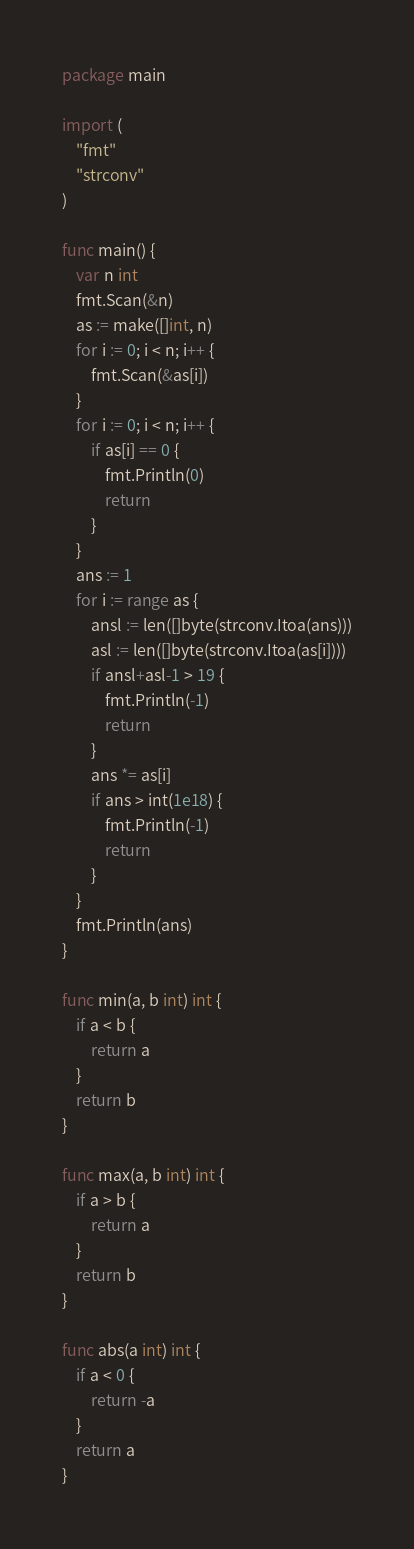Convert code to text. <code><loc_0><loc_0><loc_500><loc_500><_Go_>package main

import (
	"fmt"
	"strconv"
)

func main() {
	var n int
	fmt.Scan(&n)
	as := make([]int, n)
	for i := 0; i < n; i++ {
		fmt.Scan(&as[i])
	}
	for i := 0; i < n; i++ {
		if as[i] == 0 {
			fmt.Println(0)
			return
		}
	}
	ans := 1
	for i := range as {
		ansl := len([]byte(strconv.Itoa(ans)))
		asl := len([]byte(strconv.Itoa(as[i])))
		if ansl+asl-1 > 19 {
			fmt.Println(-1)
			return
		}
		ans *= as[i]
		if ans > int(1e18) {
			fmt.Println(-1)
			return
		}
	}
	fmt.Println(ans)
}

func min(a, b int) int {
	if a < b {
		return a
	}
	return b
}

func max(a, b int) int {
	if a > b {
		return a
	}
	return b
}

func abs(a int) int {
	if a < 0 {
		return -a
	}
	return a
}
</code> 